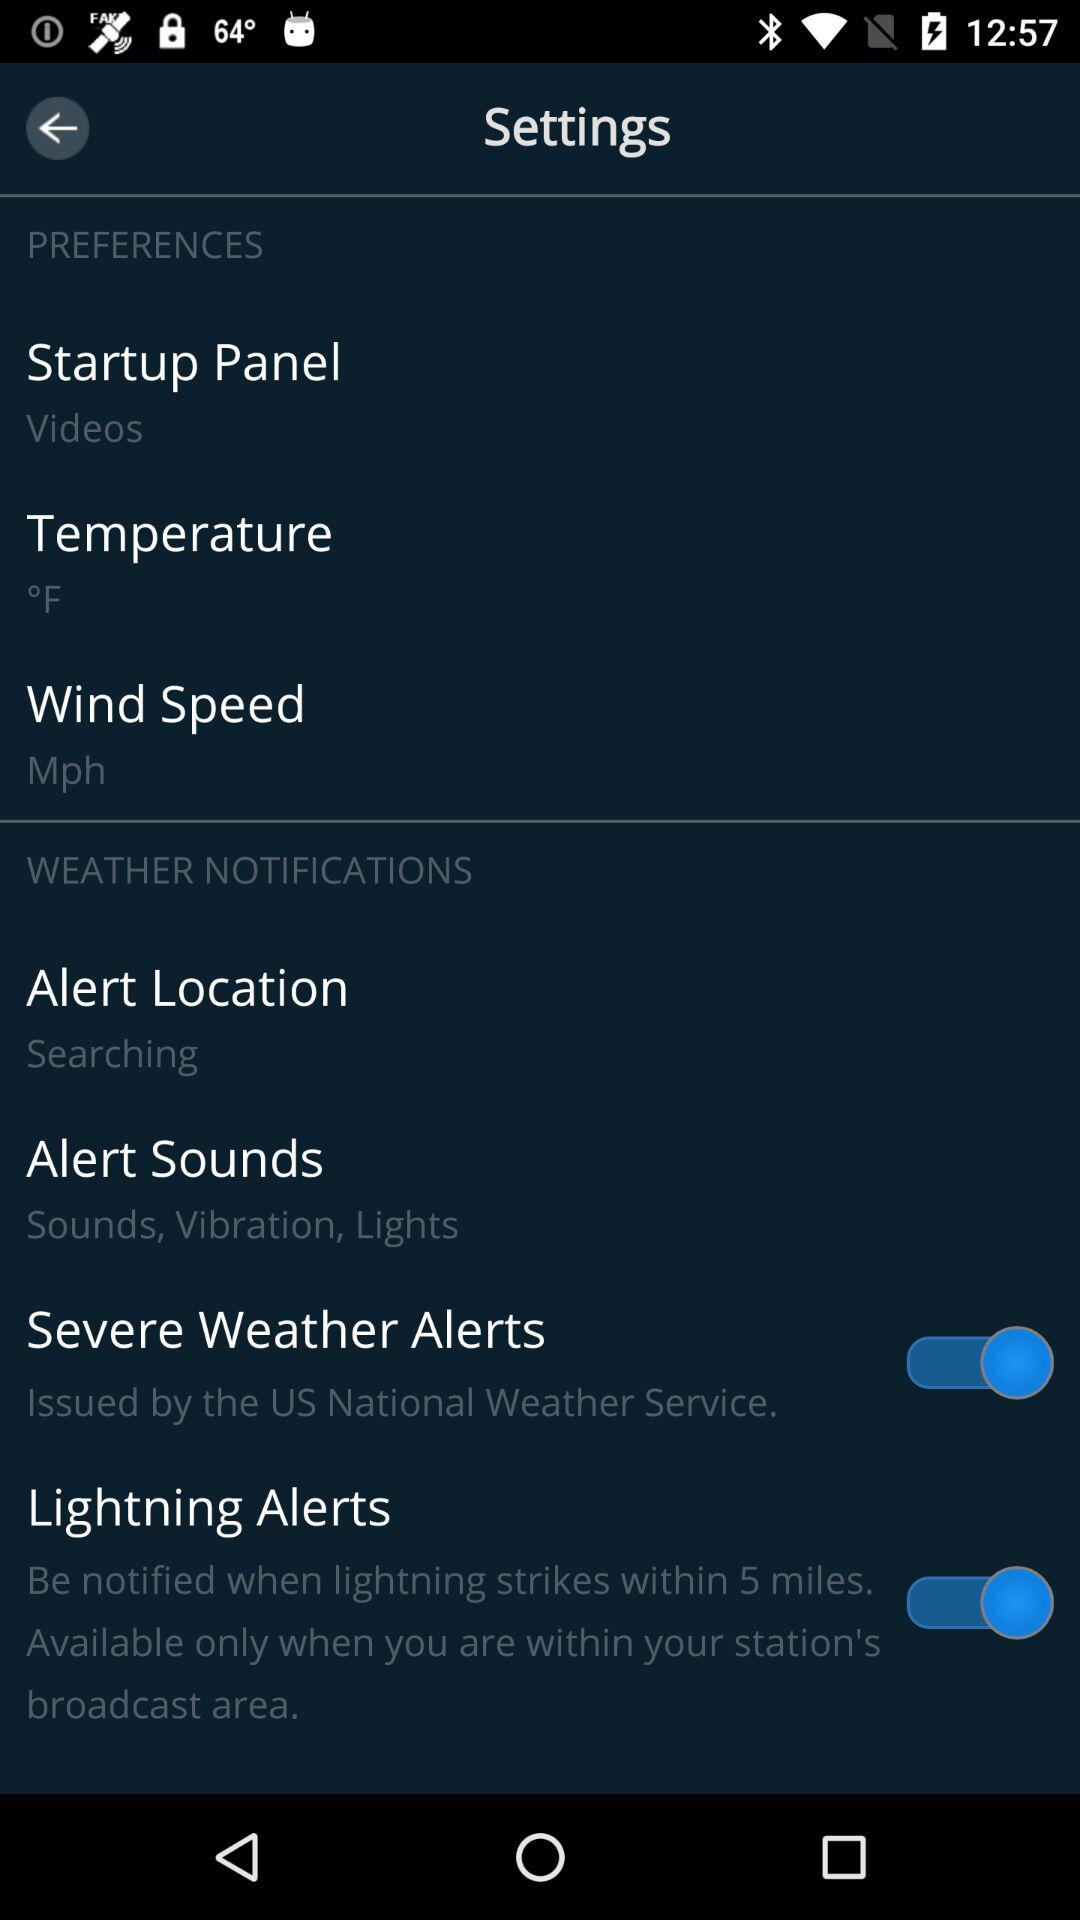What is the status of the severe weather alerts? The status is on. 